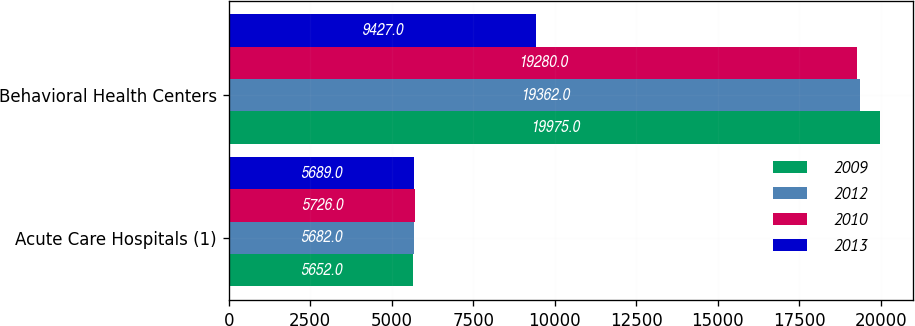<chart> <loc_0><loc_0><loc_500><loc_500><stacked_bar_chart><ecel><fcel>Acute Care Hospitals (1)<fcel>Behavioral Health Centers<nl><fcel>2009<fcel>5652<fcel>19975<nl><fcel>2012<fcel>5682<fcel>19362<nl><fcel>2010<fcel>5726<fcel>19280<nl><fcel>2013<fcel>5689<fcel>9427<nl></chart> 